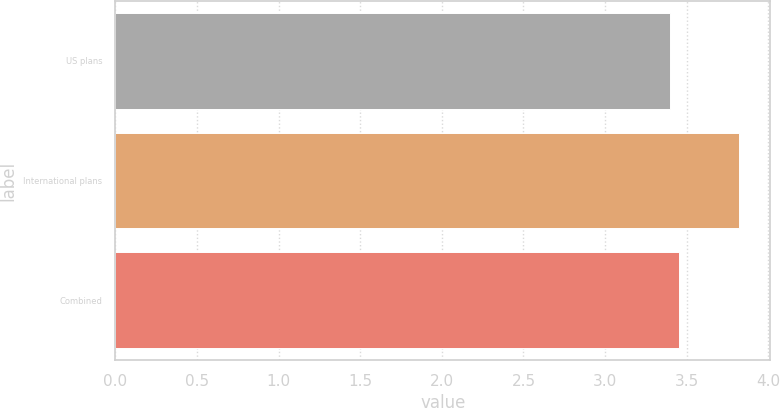Convert chart to OTSL. <chart><loc_0><loc_0><loc_500><loc_500><bar_chart><fcel>US plans<fcel>International plans<fcel>Combined<nl><fcel>3.4<fcel>3.82<fcel>3.45<nl></chart> 